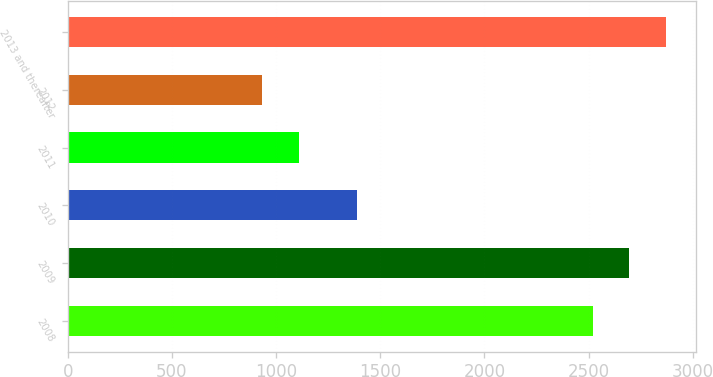<chart> <loc_0><loc_0><loc_500><loc_500><bar_chart><fcel>2008<fcel>2009<fcel>2010<fcel>2011<fcel>2012<fcel>2013 and thereafter<nl><fcel>2521<fcel>2696.5<fcel>1387<fcel>1110.5<fcel>935<fcel>2872<nl></chart> 